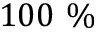Convert formula to latex. <formula><loc_0><loc_0><loc_500><loc_500>1 0 0 \%</formula> 